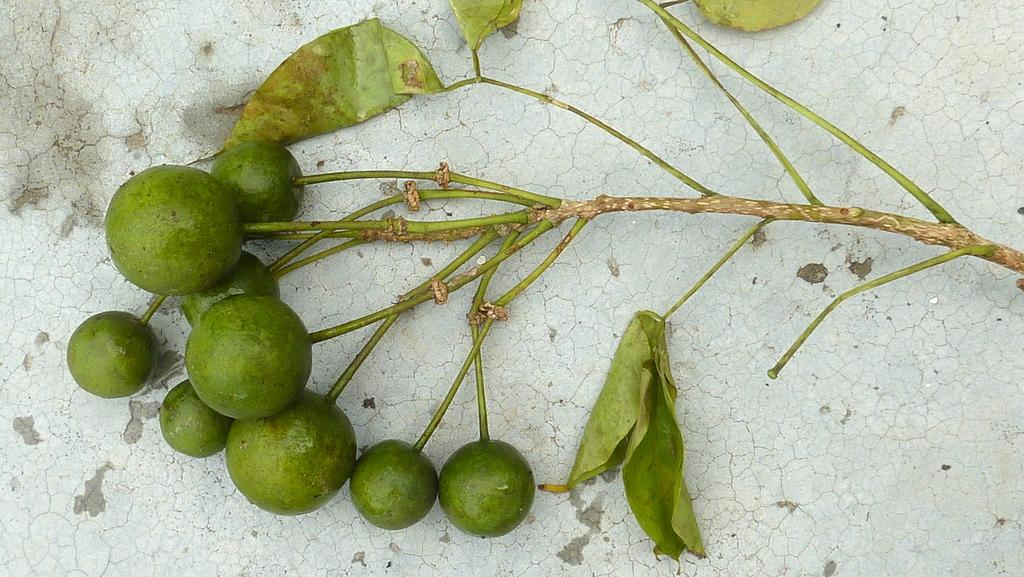What type of food items can be seen in the image? There are fruits in the image. What else is present in the image besides the fruits? There are leaves and a stem in the image. Where are the fruits, leaves, and stem located? They are on a platform in the image. How many windows are visible in the image? There are no windows present in the image; it features fruits, leaves, and a stem on a platform. 